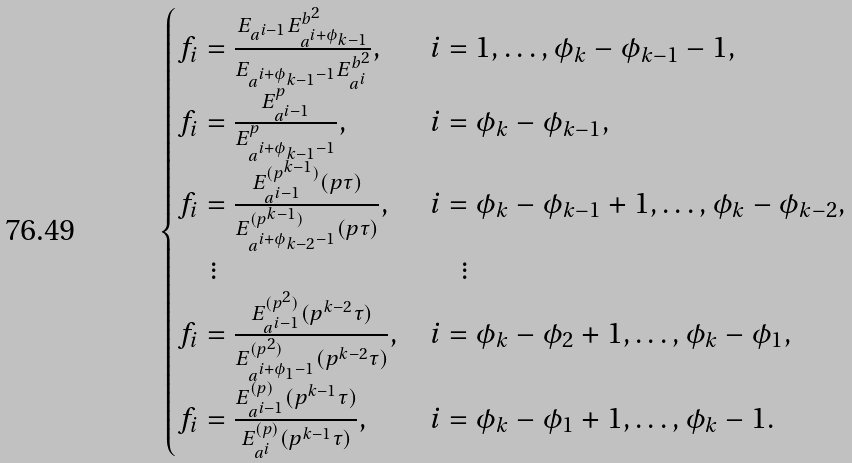<formula> <loc_0><loc_0><loc_500><loc_500>\begin{cases} f _ { i } = \frac { E _ { a ^ { i - 1 } } E _ { a ^ { i + \phi _ { k - 1 } } } ^ { b ^ { 2 } } } { E _ { a ^ { i + \phi _ { k - 1 } - 1 } } E _ { a ^ { i } } ^ { b ^ { 2 } } } , & i = 1 , \dots , \phi _ { k } - \phi _ { k - 1 } - 1 , \\ f _ { i } = \frac { E _ { a ^ { i - 1 } } ^ { p } } { E _ { a ^ { i + \phi _ { k - 1 } - 1 } } ^ { p } } , & i = \phi _ { k } - \phi _ { k - 1 } , \\ f _ { i } = \frac { E ^ { ( p ^ { k - 1 } ) } _ { a ^ { i - 1 } } ( p \tau ) } { E ^ { ( p ^ { k - 1 } ) } _ { a ^ { i + \phi _ { k - 2 } - 1 } } ( p \tau ) } , & i = \phi _ { k } - \phi _ { k - 1 } + 1 , \dots , \phi _ { k } - \phi _ { k - 2 } , \\ \quad \vdots & \quad \vdots \\ f _ { i } = \frac { E ^ { ( p ^ { 2 } ) } _ { a ^ { i - 1 } } ( p ^ { k - 2 } \tau ) } { E ^ { ( p ^ { 2 } ) } _ { a ^ { i + \phi _ { 1 } - 1 } } ( p ^ { k - 2 } \tau ) } , & i = \phi _ { k } - \phi _ { 2 } + 1 , \dots , \phi _ { k } - \phi _ { 1 } , \\ f _ { i } = \frac { E ^ { ( p ) } _ { a ^ { i - 1 } } ( p ^ { k - 1 } \tau ) } { E ^ { ( p ) } _ { a ^ { i } } ( p ^ { k - 1 } \tau ) } , & i = \phi _ { k } - \phi _ { 1 } + 1 , \dots , \phi _ { k } - 1 . \end{cases}</formula> 